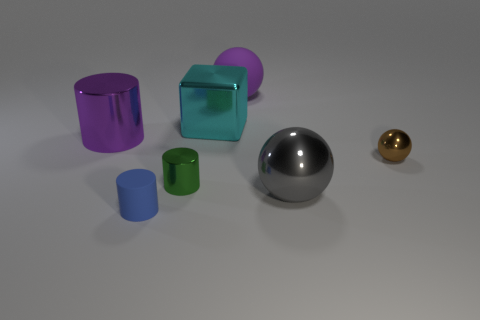What material is the tiny brown object?
Offer a very short reply. Metal. What number of other things are there of the same shape as the big purple matte object?
Your response must be concise. 2. What is the size of the green shiny object?
Provide a succinct answer. Small. What size is the sphere that is both in front of the big rubber thing and behind the large gray ball?
Make the answer very short. Small. There is a large metallic thing that is in front of the tiny ball; what shape is it?
Make the answer very short. Sphere. Do the green cylinder and the large sphere behind the large gray metal sphere have the same material?
Provide a short and direct response. No. Do the large purple matte object and the big cyan shiny object have the same shape?
Provide a succinct answer. No. There is a brown object that is the same shape as the large gray object; what material is it?
Keep it short and to the point. Metal. The tiny object that is left of the large cyan metal object and behind the tiny blue rubber cylinder is what color?
Give a very brief answer. Green. The metal block has what color?
Ensure brevity in your answer.  Cyan. 